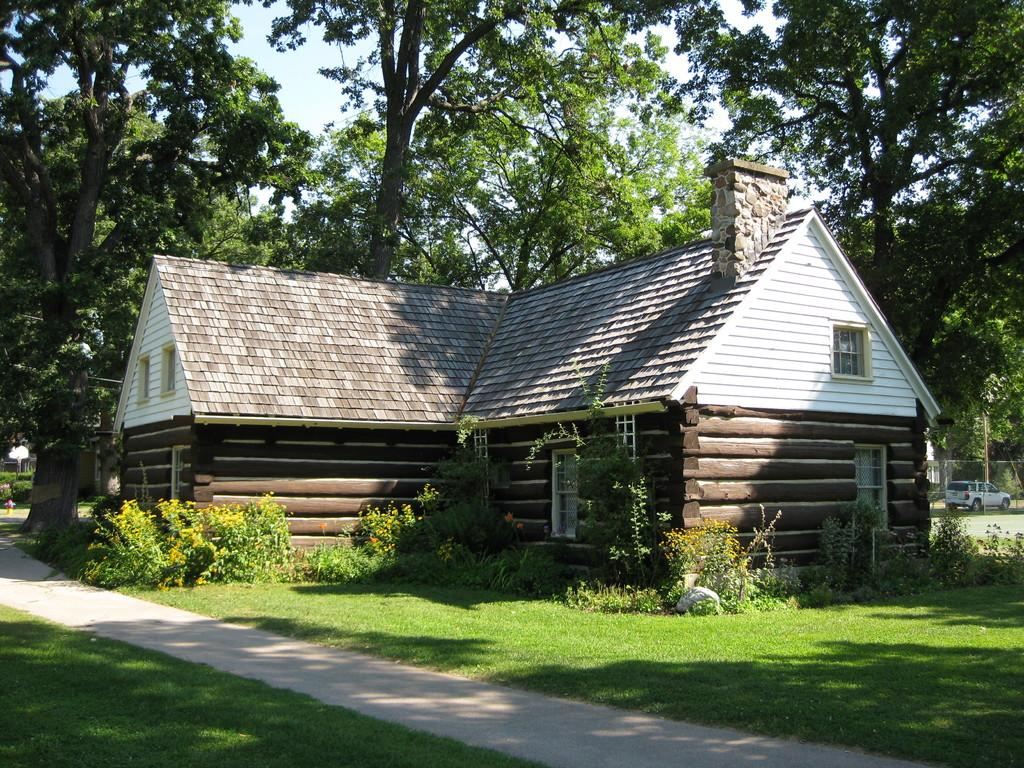What type of structure is visible in the image? There is a house in the image. What colors are used for the house? The house is in brown and cream color. What can be seen in the background of the image? There are vehicles and trees with green color in the background of the image. What is the color of the sky in the image? The sky is in white color. Can you tell me how many people are talking in the church in the image? There is no church present in the image, and therefore no people talking in a church can be observed. 